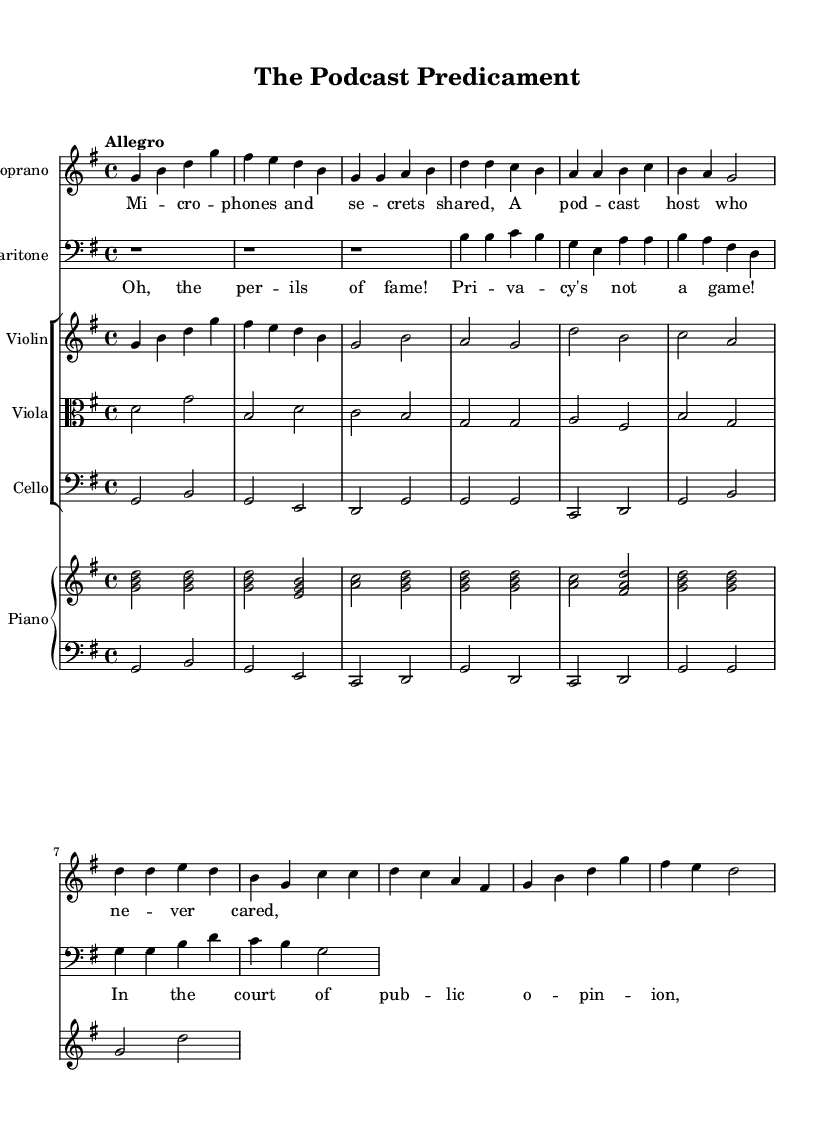What is the key signature of this music? The key signature is identified by looking at the beginning of the staff, where there are one sharp (F#) indicating the piece is in G major.
Answer: G major What is the time signature of this music? The time signature is located at the beginning of the score; it shows 4 over 4, which is a standard time signature indicating four beats per measure.
Answer: 4/4 What is the tempo marking for this piece? The tempo marking is indicated at the beginning of the score with the word "Allegro," which means to play at a brisk tempo.
Answer: Allegro How many staves are used for the piano part? To determine the number of staves for the piano part, we examine the layout, which shows a PianoStaff containing two staves: one for the right hand and one for the left hand.
Answer: Two What is the dynamic marking in the chorus section? The score provided does not include explicit dynamic markings; thus, we deduce that performers should interpret their own dynamics based on the context of the piece.
Answer: Not specified What type of opera is represented in this music? The title "The Podcast Predicament" implies that it deals with comic elements featuring media personalities, illustrating humorous misadventures.
Answer: Comic opera What instruments are included in the orchestration? By looking at the score, we can see that it includes Soprano, Baritone, Violin, Viola, Cello, and a Piano, which are common in opera orchestration.
Answer: Soprano, Baritone, Violin, Viola, Cello, Piano 